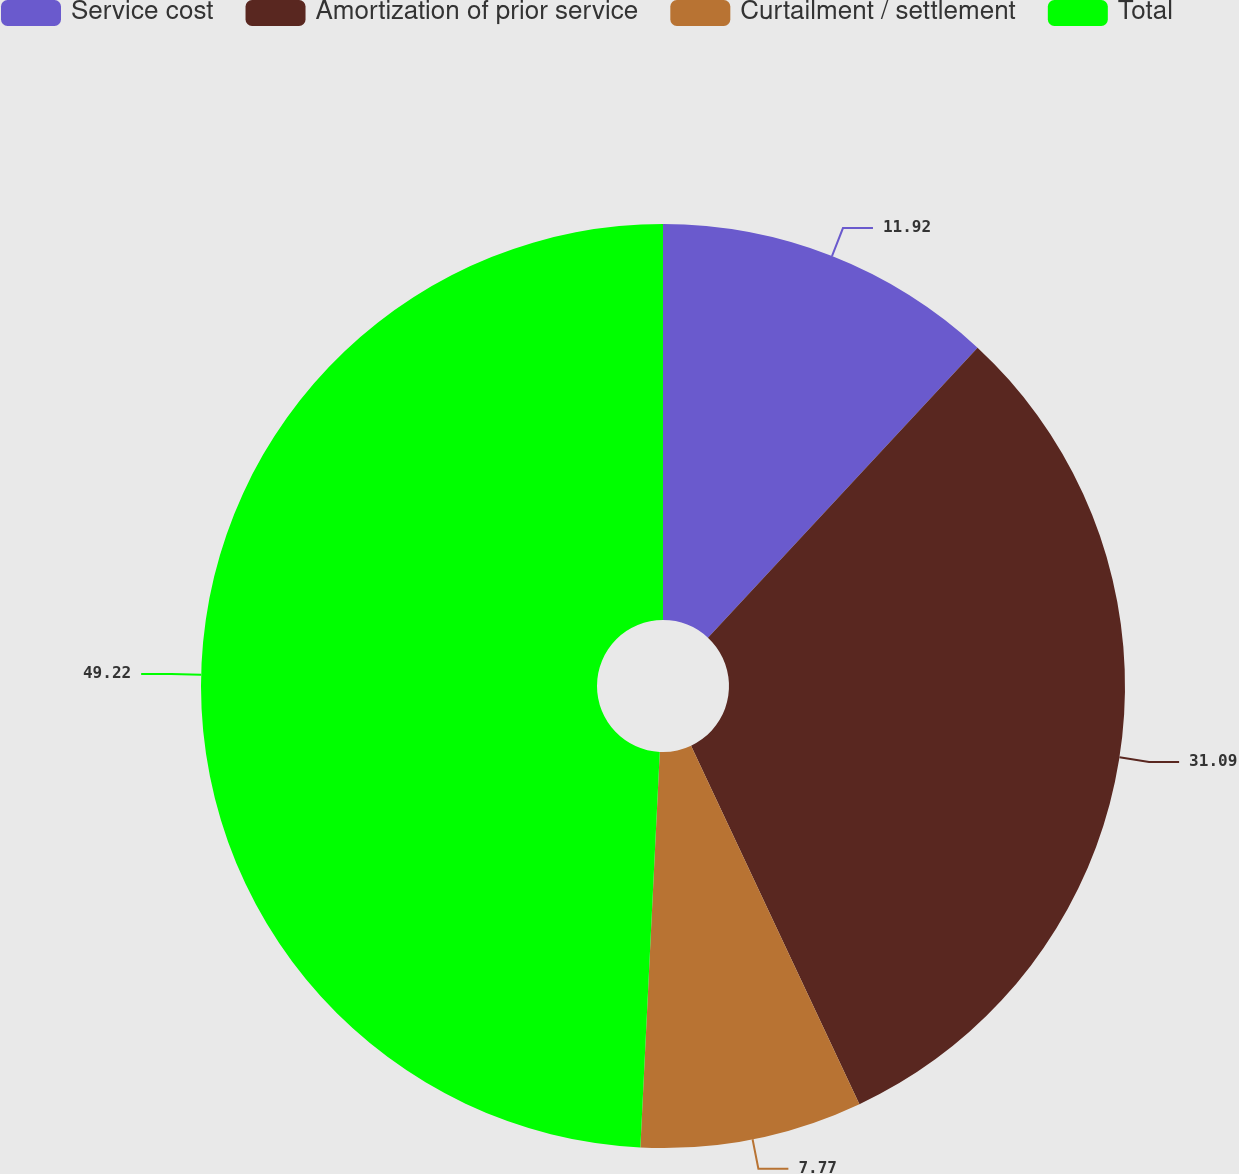<chart> <loc_0><loc_0><loc_500><loc_500><pie_chart><fcel>Service cost<fcel>Amortization of prior service<fcel>Curtailment / settlement<fcel>Total<nl><fcel>11.92%<fcel>31.09%<fcel>7.77%<fcel>49.22%<nl></chart> 